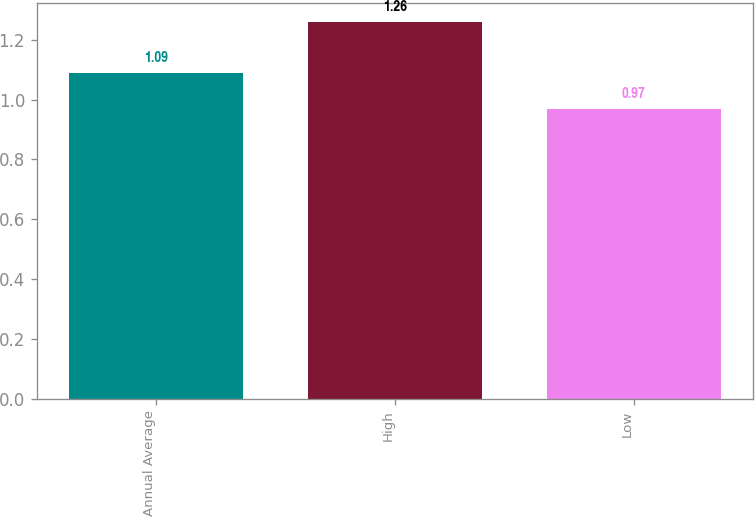Convert chart. <chart><loc_0><loc_0><loc_500><loc_500><bar_chart><fcel>Annual Average<fcel>High<fcel>Low<nl><fcel>1.09<fcel>1.26<fcel>0.97<nl></chart> 